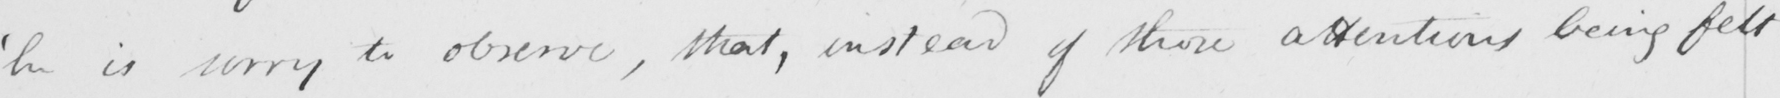What text is written in this handwritten line? ' he is sorry to observe , that , instead of those attentions being felt 